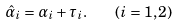<formula> <loc_0><loc_0><loc_500><loc_500>\hat { \alpha } _ { i } = \alpha _ { i } + \tau _ { i } . \quad ( i = 1 , 2 )</formula> 